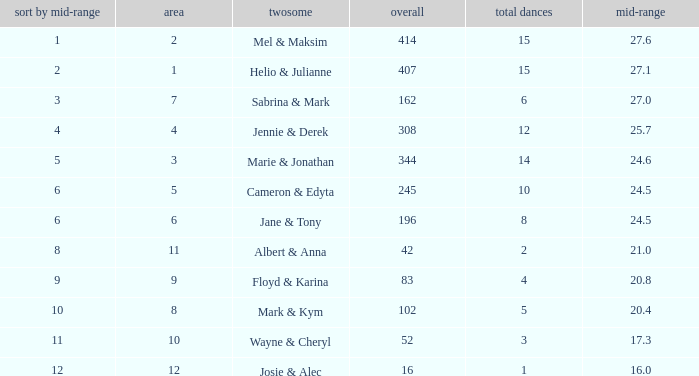In a situation where the total score surpassed 245, the average score was 27.1, and there were under 15 dances, what is the rank based on the average? None. Give me the full table as a dictionary. {'header': ['sort by mid-range', 'area', 'twosome', 'overall', 'total dances', 'mid-range'], 'rows': [['1', '2', 'Mel & Maksim', '414', '15', '27.6'], ['2', '1', 'Helio & Julianne', '407', '15', '27.1'], ['3', '7', 'Sabrina & Mark', '162', '6', '27.0'], ['4', '4', 'Jennie & Derek', '308', '12', '25.7'], ['5', '3', 'Marie & Jonathan', '344', '14', '24.6'], ['6', '5', 'Cameron & Edyta', '245', '10', '24.5'], ['6', '6', 'Jane & Tony', '196', '8', '24.5'], ['8', '11', 'Albert & Anna', '42', '2', '21.0'], ['9', '9', 'Floyd & Karina', '83', '4', '20.8'], ['10', '8', 'Mark & Kym', '102', '5', '20.4'], ['11', '10', 'Wayne & Cheryl', '52', '3', '17.3'], ['12', '12', 'Josie & Alec', '16', '1', '16.0']]} 